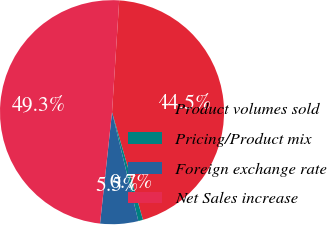Convert chart to OTSL. <chart><loc_0><loc_0><loc_500><loc_500><pie_chart><fcel>Product volumes sold<fcel>Pricing/Product mix<fcel>Foreign exchange rate<fcel>Net Sales increase<nl><fcel>44.52%<fcel>0.68%<fcel>5.48%<fcel>49.32%<nl></chart> 